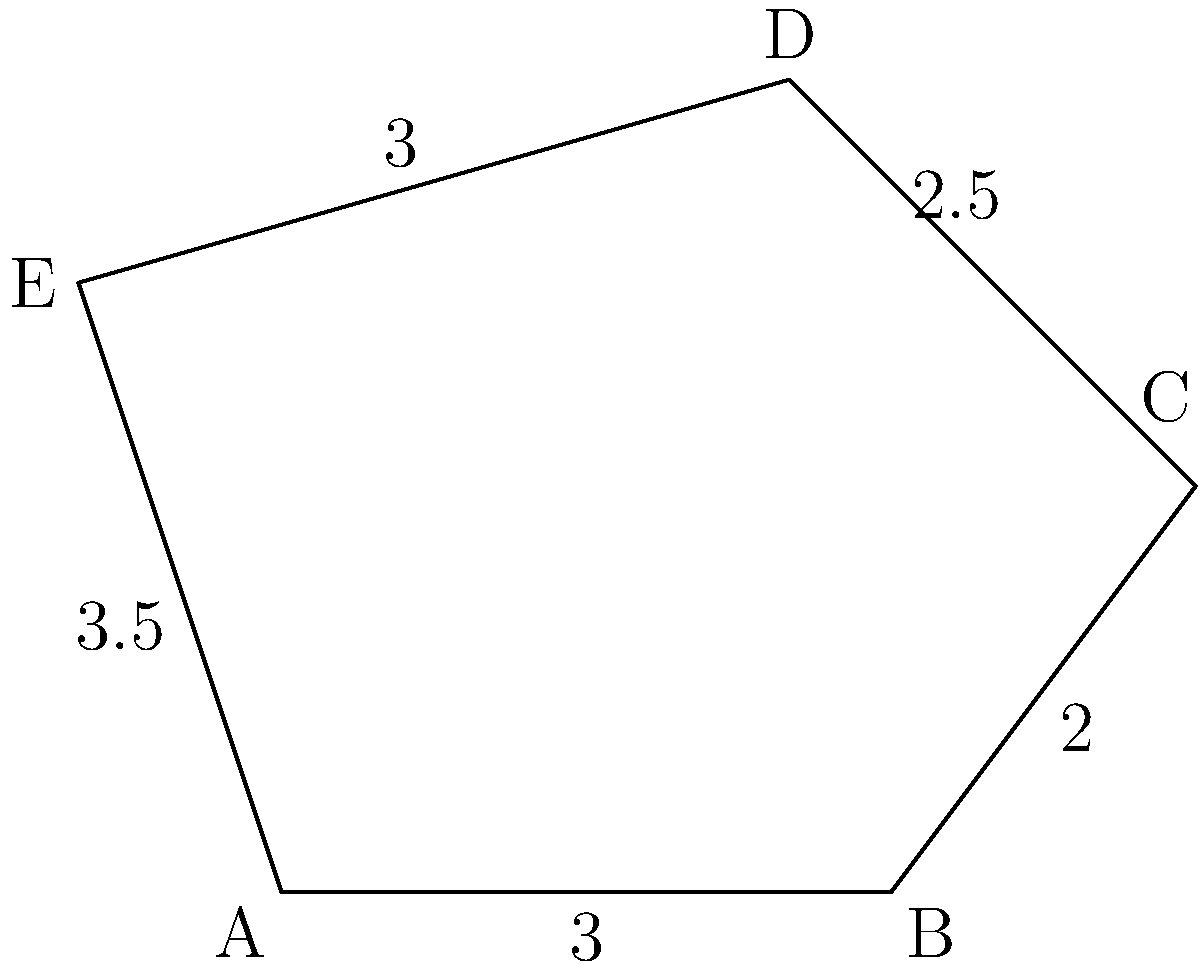As part of an eco-friendly film festival, you're designing a recycling bin with a pentagonal base. The side lengths of the pentagonal base are 3 m, 2 m, 2.5 m, 3 m, and 3.5 m. What is the perimeter of the base in meters? To find the perimeter of the pentagonal base, we need to sum up all the side lengths:

1. Side AB = 3 m
2. Side BC = 2 m
3. Side CD = 2.5 m
4. Side DE = 3 m
5. Side EA = 3.5 m

Now, let's add these lengths:

$$\text{Perimeter} = 3 + 2 + 2.5 + 3 + 3.5 = 14 \text{ m}$$

Therefore, the perimeter of the pentagonal base is 14 meters.
Answer: 14 m 